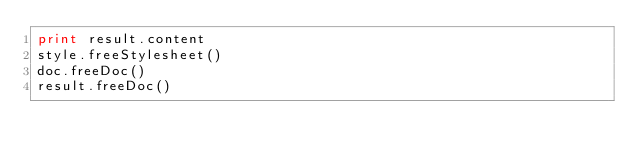<code> <loc_0><loc_0><loc_500><loc_500><_Python_>print result.content
style.freeStylesheet()
doc.freeDoc()
result.freeDoc()
</code> 